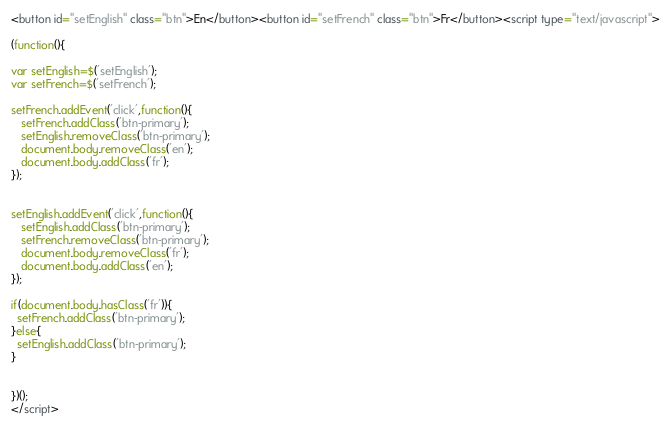Convert code to text. <code><loc_0><loc_0><loc_500><loc_500><_HTML_><button id="setEnglish" class="btn">En</button><button id="setFrench" class="btn">Fr</button><script type="text/javascript">

(function(){

var setEnglish=$('setEnglish');
var setFrench=$('setFrench');

setFrench.addEvent('click',function(){
   setFrench.addClass('btn-primary');
   setEnglish.removeClass('btn-primary');
   document.body.removeClass('en');
   document.body.addClass('fr');
});


setEnglish.addEvent('click',function(){
   setEnglish.addClass('btn-primary');
   setFrench.removeClass('btn-primary');
   document.body.removeClass('fr');
   document.body.addClass('en');
});

if(document.body.hasClass('fr')){
  setFrench.addClass('btn-primary');
}else{
  setEnglish.addClass('btn-primary');
}


})();
</script></code> 